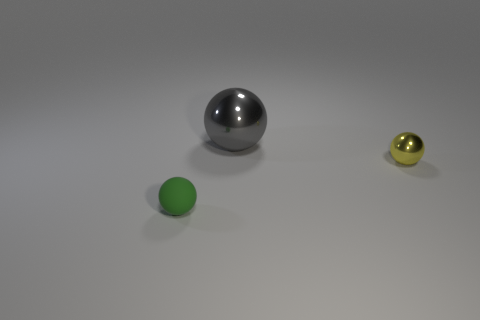Add 3 big spheres. How many objects exist? 6 Subtract 0 green cylinders. How many objects are left? 3 Subtract all tiny balls. Subtract all small yellow spheres. How many objects are left? 0 Add 2 objects. How many objects are left? 5 Add 1 large yellow rubber cylinders. How many large yellow rubber cylinders exist? 1 